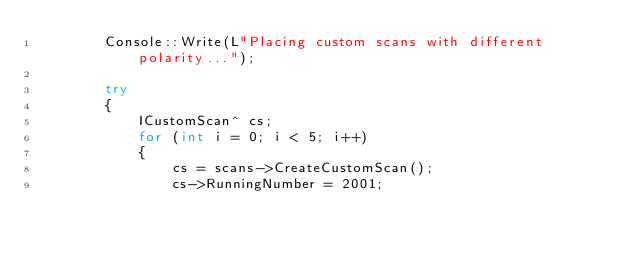<code> <loc_0><loc_0><loc_500><loc_500><_C++_>		Console::Write(L"Placing custom scans with different polarity...");

		try
		{
			ICustomScan^ cs;
			for (int i = 0; i < 5; i++)
			{
				cs = scans->CreateCustomScan();
				cs->RunningNumber = 2001;</code> 